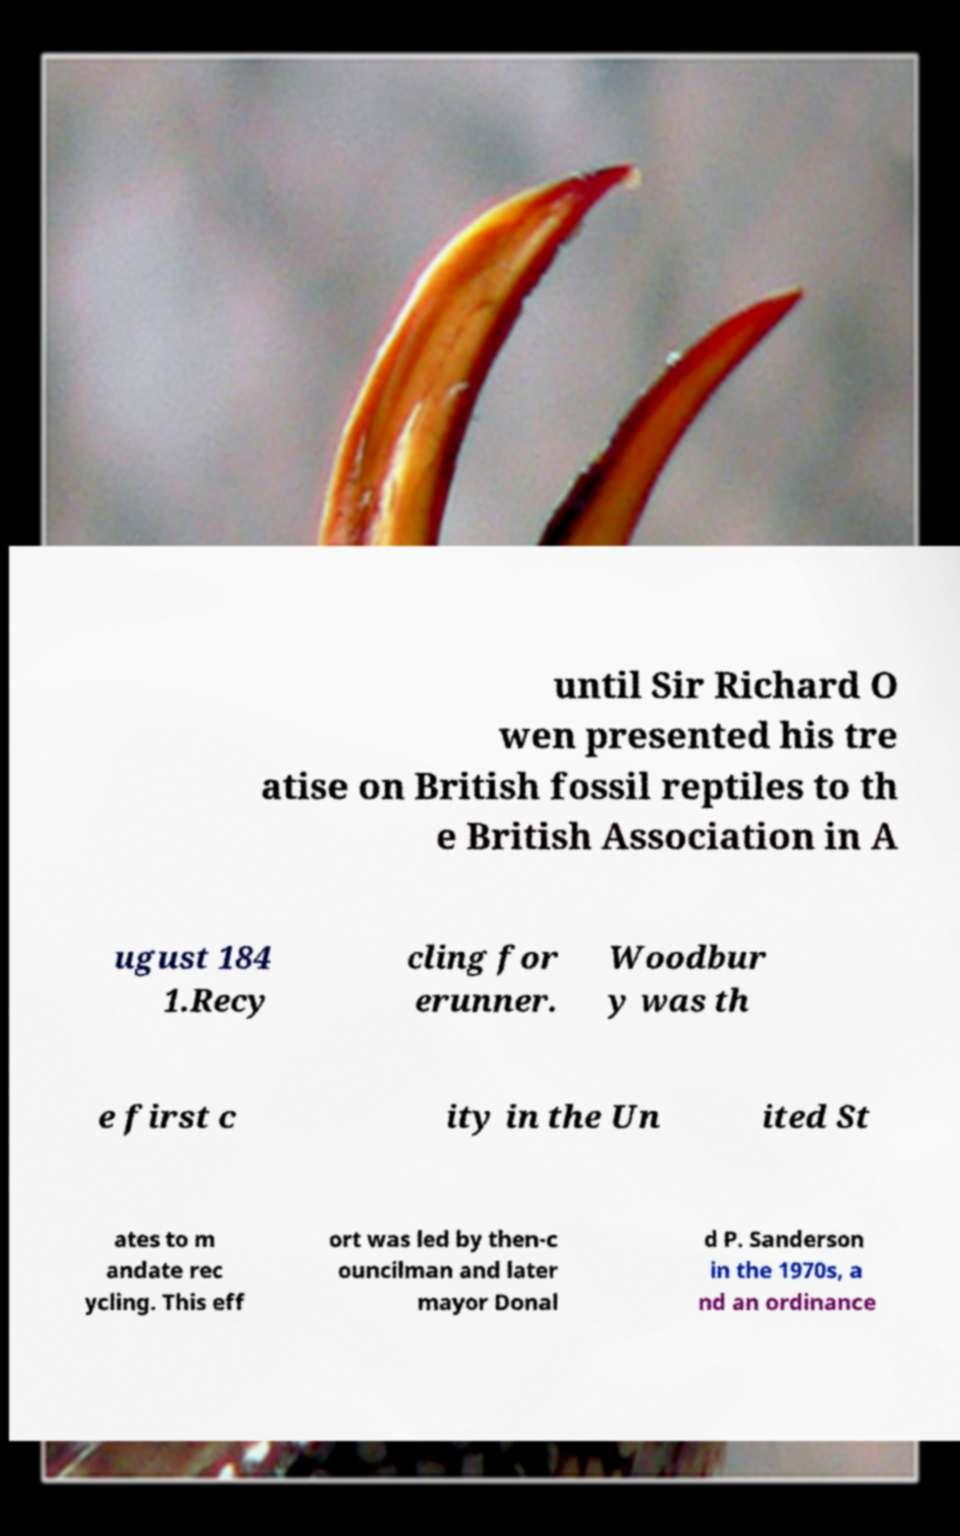Could you assist in decoding the text presented in this image and type it out clearly? until Sir Richard O wen presented his tre atise on British fossil reptiles to th e British Association in A ugust 184 1.Recy cling for erunner. Woodbur y was th e first c ity in the Un ited St ates to m andate rec ycling. This eff ort was led by then-c ouncilman and later mayor Donal d P. Sanderson in the 1970s, a nd an ordinance 